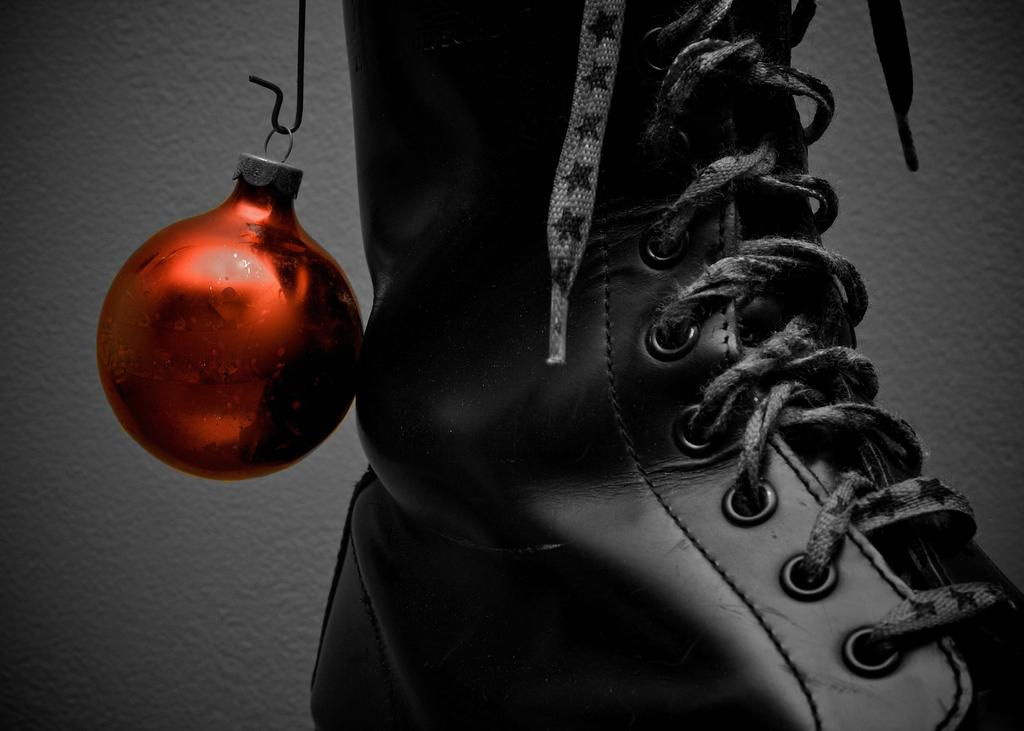What object can be seen in the image that people wear on their feet? There is a shoe in the image. What type of ball is present in the image? There is a ball with a ring in the image. How is the ball with a ring positioned in the image? The ball with a ring is placed on a hook. What emotion does the shoe in the image appear to be feeling? Shoes do not have emotions, so it is not possible to determine how the shoe in the image might be feeling. 